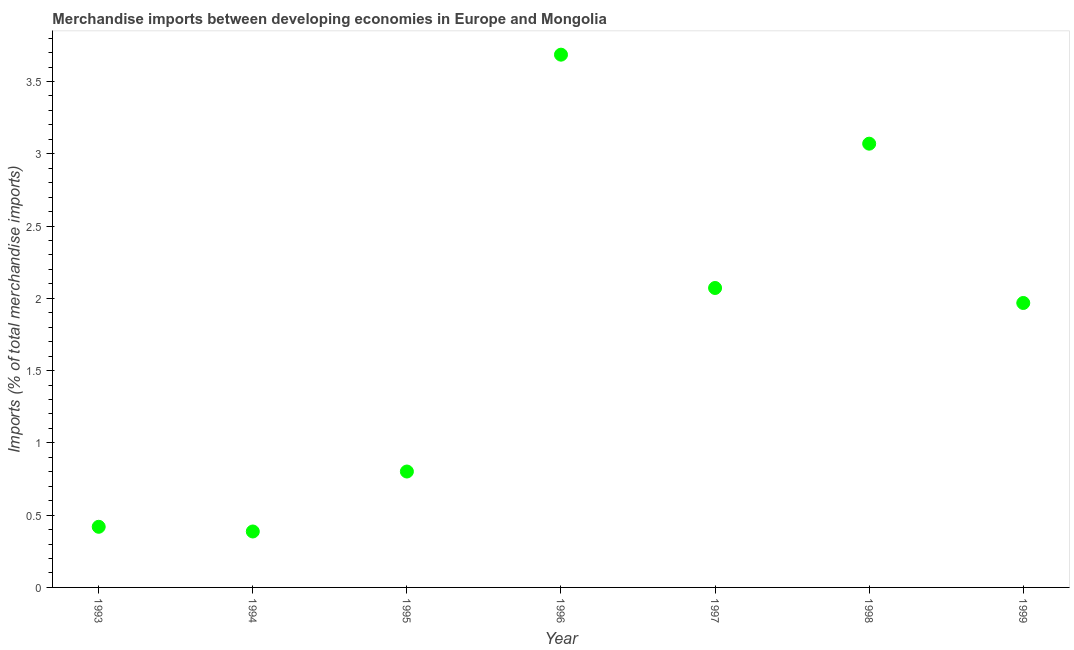What is the merchandise imports in 1994?
Keep it short and to the point. 0.39. Across all years, what is the maximum merchandise imports?
Your response must be concise. 3.69. Across all years, what is the minimum merchandise imports?
Offer a very short reply. 0.39. What is the sum of the merchandise imports?
Keep it short and to the point. 12.4. What is the difference between the merchandise imports in 1993 and 1997?
Your answer should be compact. -1.65. What is the average merchandise imports per year?
Your answer should be compact. 1.77. What is the median merchandise imports?
Give a very brief answer. 1.97. In how many years, is the merchandise imports greater than 2.8 %?
Give a very brief answer. 2. What is the ratio of the merchandise imports in 1993 to that in 1999?
Ensure brevity in your answer.  0.21. Is the difference between the merchandise imports in 1994 and 1998 greater than the difference between any two years?
Ensure brevity in your answer.  No. What is the difference between the highest and the second highest merchandise imports?
Offer a terse response. 0.62. What is the difference between the highest and the lowest merchandise imports?
Your response must be concise. 3.3. In how many years, is the merchandise imports greater than the average merchandise imports taken over all years?
Keep it short and to the point. 4. How many years are there in the graph?
Offer a very short reply. 7. What is the difference between two consecutive major ticks on the Y-axis?
Offer a terse response. 0.5. Does the graph contain any zero values?
Your response must be concise. No. What is the title of the graph?
Provide a short and direct response. Merchandise imports between developing economies in Europe and Mongolia. What is the label or title of the X-axis?
Offer a terse response. Year. What is the label or title of the Y-axis?
Provide a succinct answer. Imports (% of total merchandise imports). What is the Imports (% of total merchandise imports) in 1993?
Ensure brevity in your answer.  0.42. What is the Imports (% of total merchandise imports) in 1994?
Offer a very short reply. 0.39. What is the Imports (% of total merchandise imports) in 1995?
Keep it short and to the point. 0.8. What is the Imports (% of total merchandise imports) in 1996?
Keep it short and to the point. 3.69. What is the Imports (% of total merchandise imports) in 1997?
Provide a succinct answer. 2.07. What is the Imports (% of total merchandise imports) in 1998?
Offer a terse response. 3.07. What is the Imports (% of total merchandise imports) in 1999?
Provide a short and direct response. 1.97. What is the difference between the Imports (% of total merchandise imports) in 1993 and 1994?
Your response must be concise. 0.03. What is the difference between the Imports (% of total merchandise imports) in 1993 and 1995?
Ensure brevity in your answer.  -0.38. What is the difference between the Imports (% of total merchandise imports) in 1993 and 1996?
Give a very brief answer. -3.27. What is the difference between the Imports (% of total merchandise imports) in 1993 and 1997?
Provide a short and direct response. -1.65. What is the difference between the Imports (% of total merchandise imports) in 1993 and 1998?
Offer a very short reply. -2.65. What is the difference between the Imports (% of total merchandise imports) in 1993 and 1999?
Offer a terse response. -1.55. What is the difference between the Imports (% of total merchandise imports) in 1994 and 1995?
Your response must be concise. -0.41. What is the difference between the Imports (% of total merchandise imports) in 1994 and 1996?
Keep it short and to the point. -3.3. What is the difference between the Imports (% of total merchandise imports) in 1994 and 1997?
Offer a very short reply. -1.68. What is the difference between the Imports (% of total merchandise imports) in 1994 and 1998?
Offer a very short reply. -2.68. What is the difference between the Imports (% of total merchandise imports) in 1994 and 1999?
Keep it short and to the point. -1.58. What is the difference between the Imports (% of total merchandise imports) in 1995 and 1996?
Offer a terse response. -2.88. What is the difference between the Imports (% of total merchandise imports) in 1995 and 1997?
Make the answer very short. -1.27. What is the difference between the Imports (% of total merchandise imports) in 1995 and 1998?
Offer a terse response. -2.27. What is the difference between the Imports (% of total merchandise imports) in 1995 and 1999?
Provide a succinct answer. -1.17. What is the difference between the Imports (% of total merchandise imports) in 1996 and 1997?
Your answer should be very brief. 1.61. What is the difference between the Imports (% of total merchandise imports) in 1996 and 1998?
Make the answer very short. 0.62. What is the difference between the Imports (% of total merchandise imports) in 1996 and 1999?
Offer a terse response. 1.72. What is the difference between the Imports (% of total merchandise imports) in 1997 and 1998?
Ensure brevity in your answer.  -1. What is the difference between the Imports (% of total merchandise imports) in 1997 and 1999?
Your answer should be compact. 0.1. What is the difference between the Imports (% of total merchandise imports) in 1998 and 1999?
Give a very brief answer. 1.1. What is the ratio of the Imports (% of total merchandise imports) in 1993 to that in 1994?
Your response must be concise. 1.08. What is the ratio of the Imports (% of total merchandise imports) in 1993 to that in 1995?
Keep it short and to the point. 0.52. What is the ratio of the Imports (% of total merchandise imports) in 1993 to that in 1996?
Ensure brevity in your answer.  0.11. What is the ratio of the Imports (% of total merchandise imports) in 1993 to that in 1997?
Your response must be concise. 0.2. What is the ratio of the Imports (% of total merchandise imports) in 1993 to that in 1998?
Provide a succinct answer. 0.14. What is the ratio of the Imports (% of total merchandise imports) in 1993 to that in 1999?
Make the answer very short. 0.21. What is the ratio of the Imports (% of total merchandise imports) in 1994 to that in 1995?
Offer a very short reply. 0.48. What is the ratio of the Imports (% of total merchandise imports) in 1994 to that in 1996?
Ensure brevity in your answer.  0.1. What is the ratio of the Imports (% of total merchandise imports) in 1994 to that in 1997?
Your answer should be compact. 0.19. What is the ratio of the Imports (% of total merchandise imports) in 1994 to that in 1998?
Make the answer very short. 0.13. What is the ratio of the Imports (% of total merchandise imports) in 1994 to that in 1999?
Make the answer very short. 0.2. What is the ratio of the Imports (% of total merchandise imports) in 1995 to that in 1996?
Provide a succinct answer. 0.22. What is the ratio of the Imports (% of total merchandise imports) in 1995 to that in 1997?
Your response must be concise. 0.39. What is the ratio of the Imports (% of total merchandise imports) in 1995 to that in 1998?
Your answer should be compact. 0.26. What is the ratio of the Imports (% of total merchandise imports) in 1995 to that in 1999?
Make the answer very short. 0.41. What is the ratio of the Imports (% of total merchandise imports) in 1996 to that in 1997?
Ensure brevity in your answer.  1.78. What is the ratio of the Imports (% of total merchandise imports) in 1996 to that in 1998?
Make the answer very short. 1.2. What is the ratio of the Imports (% of total merchandise imports) in 1996 to that in 1999?
Give a very brief answer. 1.87. What is the ratio of the Imports (% of total merchandise imports) in 1997 to that in 1998?
Your response must be concise. 0.68. What is the ratio of the Imports (% of total merchandise imports) in 1997 to that in 1999?
Keep it short and to the point. 1.05. What is the ratio of the Imports (% of total merchandise imports) in 1998 to that in 1999?
Provide a short and direct response. 1.56. 